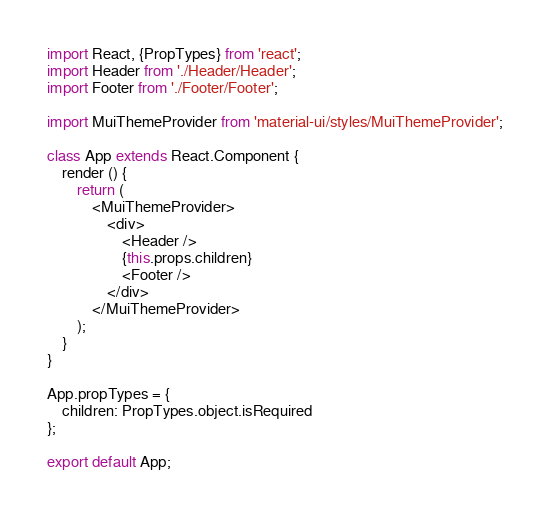<code> <loc_0><loc_0><loc_500><loc_500><_JavaScript_>import React, {PropTypes} from 'react';
import Header from './Header/Header';
import Footer from './Footer/Footer';

import MuiThemeProvider from 'material-ui/styles/MuiThemeProvider';

class App extends React.Component {
    render () {
        return (
            <MuiThemeProvider>
                <div>
                    <Header />
                    {this.props.children}
                    <Footer />
                </div>
            </MuiThemeProvider>
        );
    }
}

App.propTypes = {
    children: PropTypes.object.isRequired
};

export default App;
</code> 